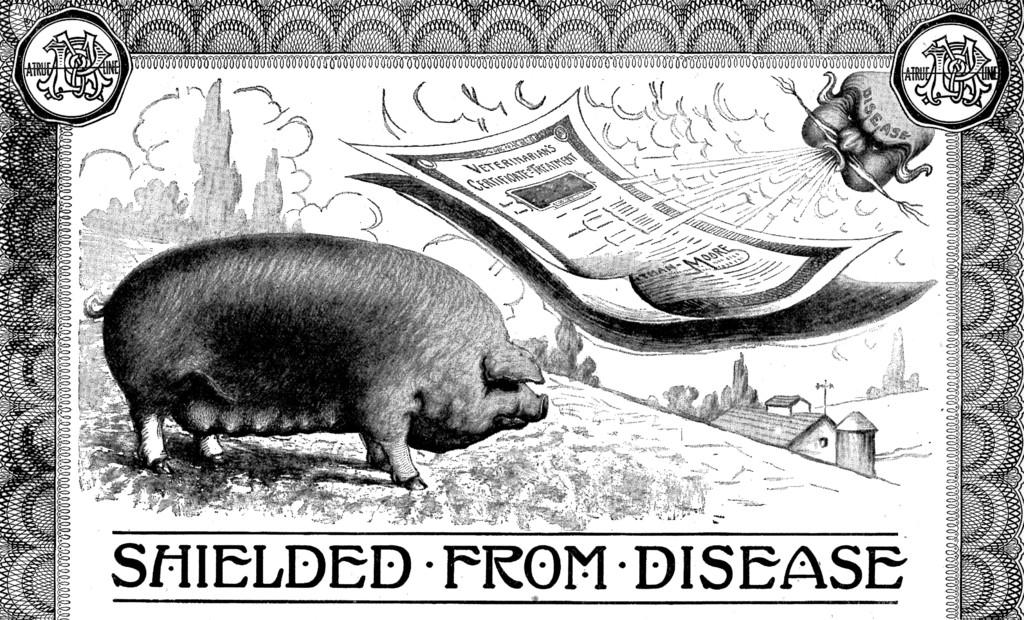What type of artwork is depicted in the image? The image is a painting. What animal can be seen in the painting? There is a pig in the painting. What objects are present in the painting? There is a paper, a tree, and a house in the painting. Is there any text in the image? Yes, text is written at the bottom of the image. Can you see any cobwebs on the roof of the house in the painting? There is no roof or cobwebs present in the image; it features a house without a roof. 